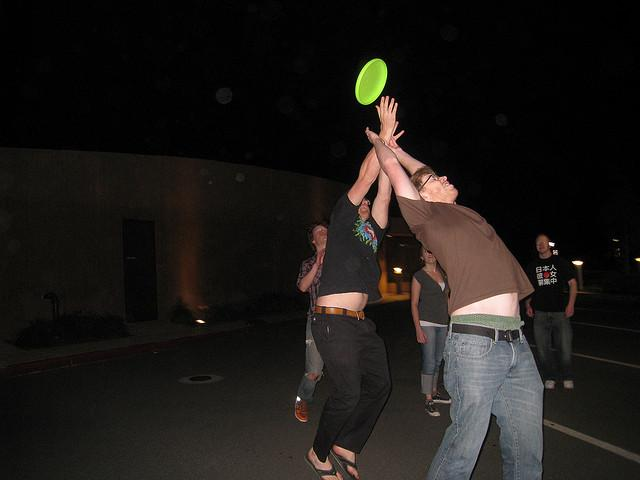WHat language is on the black shirt? Please explain your reasoning. chinese. The language is chinese. 